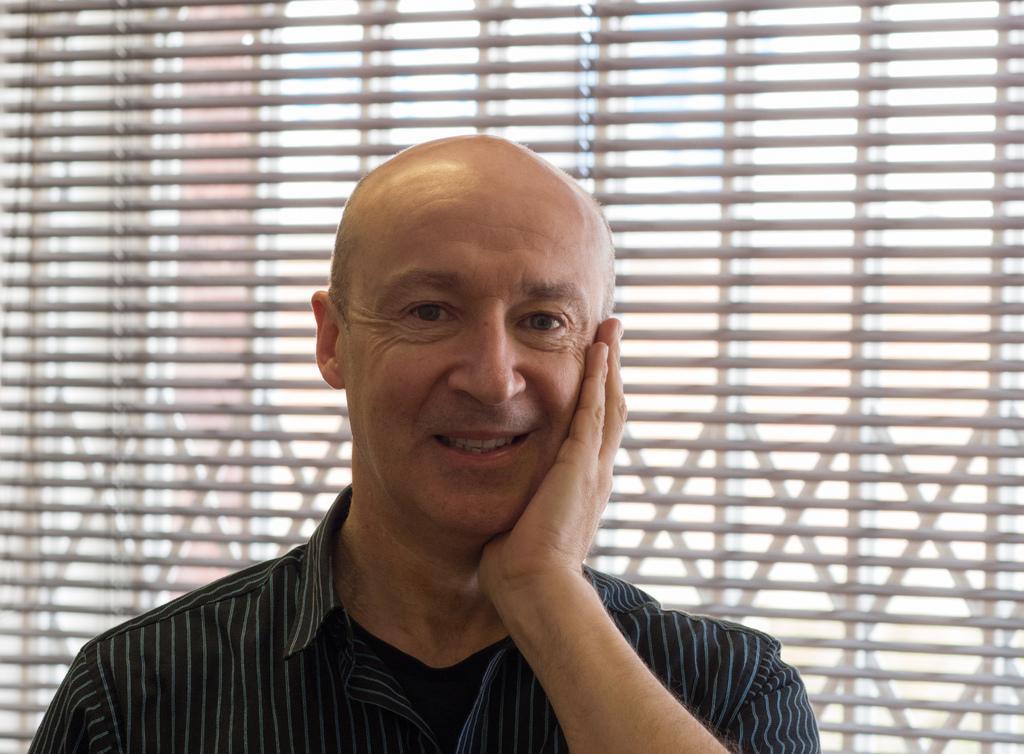Could you give a brief overview of what you see in this image? In the picture I can see one person and he's smiling. 